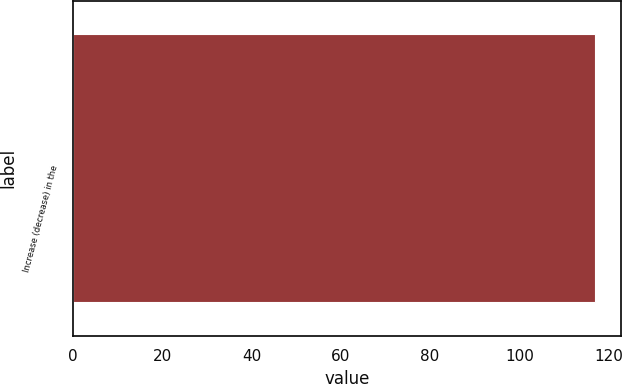<chart> <loc_0><loc_0><loc_500><loc_500><bar_chart><fcel>Increase (decrease) in the<nl><fcel>117<nl></chart> 